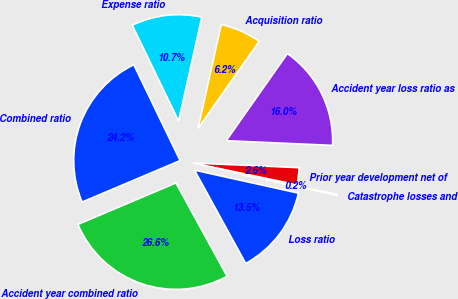Convert chart to OTSL. <chart><loc_0><loc_0><loc_500><loc_500><pie_chart><fcel>Loss ratio<fcel>Catastrophe losses and<fcel>Prior year development net of<fcel>Accident year loss ratio as<fcel>Acquisition ratio<fcel>Expense ratio<fcel>Combined ratio<fcel>Accident year combined ratio<nl><fcel>13.55%<fcel>0.17%<fcel>2.59%<fcel>15.96%<fcel>6.25%<fcel>10.66%<fcel>24.21%<fcel>26.62%<nl></chart> 